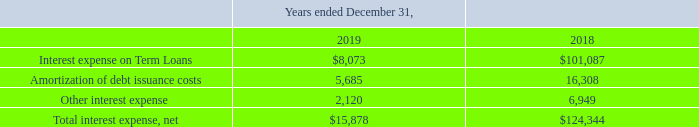9. Debt
Silicon Valley Bank Facility
We maintained a Loan and Security Agreement with SVB (the "Credit Facility") under which we had a term loan with an original borrowing amount of $6.0 million (the “Original Term Loan”). The Original Term Loan carried a floating annual interest rate equal to SVB’s prime rate then in effect plus 2%. The Original Term Loan matured and was repaid in May 2019.
On October 10, 2019, we entered into an Amended and Restated Loan and Security Agreement (the “Loan Agreement”) with SVB, which amended and restated in its entirety our previous Credit Facility. Under the Loan Agreement, SVB agreed to make advances available up to $10.0 million (the “Revolving Line”). If we borrow from the Revolving Line, such borrowing would carry a floating annual interest rate equal to the greater of (i) the Prime Rate (as defined in the Loan Agreement) then in effect plus 1% or (ii) 6%. Amounts borrowed under the Revolving Line may be repaid and, prior to the Revolving Line Maturity Date (defined below), reborrowed. The Revolving Line terminates on October 10, 2020 (the “Revolving Line Maturity Date”), unless earlier terminated by us. No amounts have been borrowed under this Loan Agreement.
Amounts due under the Loan Agreement are secured by our assets, including all personal property, inventory and bank accounts; however, intellectual property is not secured under the Loan Agreement. The inventory used to secure the amount due does not include demo or loaner equipment with an aggregate book value up to $1.0 million. The Loan Agreement requires us to observe a number of financial and operational covenants, including maintenance of a specified Liquidity Coverage Ratio (as defined in the Loan Agreement), protection and registration of intellectual property rights and customary negative covenants. If any event of default occurs SVB may declare due immediately all borrowings under the Credit Facility and foreclose on the collateral. Furthermore, an event of default under the Credit Facility would result in an increase in the interest rate on any amounts outstanding. As of December 31, 2019, there were no events of default on the Credit Facility.
Interest expense, net for the years ended December 31, 2019 and 2018 consisted of the following:
When was Original Term Loan matured and was repaid? May 2019. What is the change in Interest expense on Term Loans between December 31, 2018 and 2019? 8,073-101,087
Answer: -93014. What is the average Interest expense on Term Loans for December 31, 2018 and 2019? (8,073+101,087) / 2
Answer: 54580. In which year was Interest expense on Term Loans greater than 100,000? Locate and analyze interest expense on term loans in row 3
answer: 2018. What was the Amortization of debt issuance costs in 2019 and 2018 respectively? 5,685, 16,308. What was the Total interest expense, net in 2019 and 2018 respectively? $15,878, $124,344. 